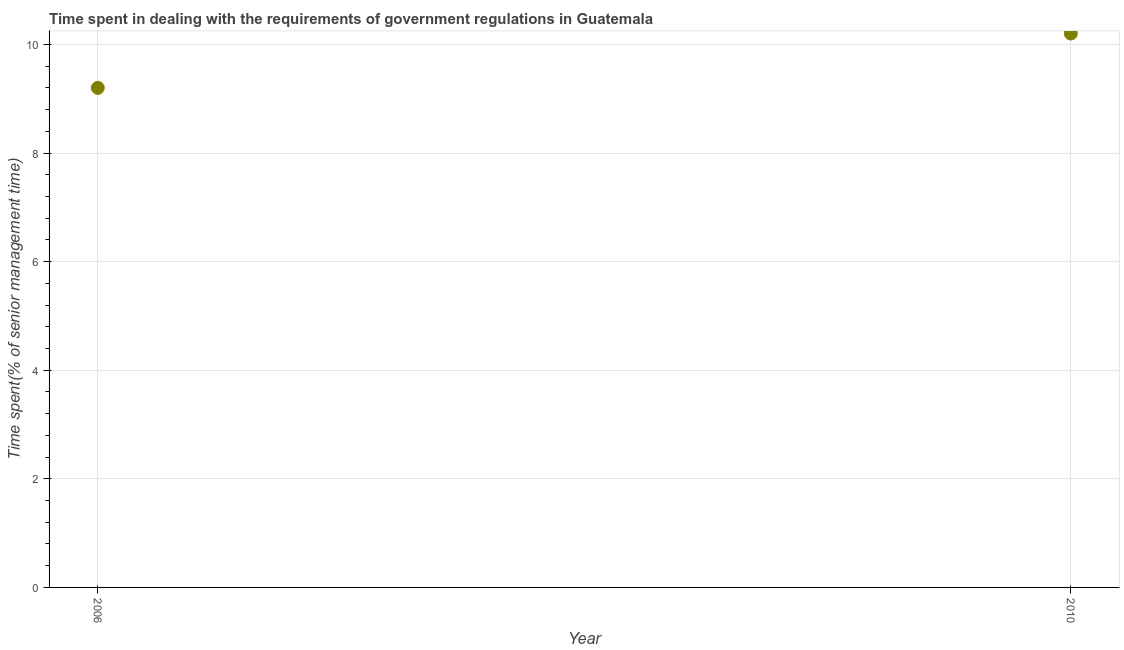Across all years, what is the minimum time spent in dealing with government regulations?
Offer a very short reply. 9.2. What is the difference between the time spent in dealing with government regulations in 2006 and 2010?
Your response must be concise. -1. What is the average time spent in dealing with government regulations per year?
Your answer should be very brief. 9.7. In how many years, is the time spent in dealing with government regulations greater than 8.4 %?
Provide a succinct answer. 2. Do a majority of the years between 2006 and 2010 (inclusive) have time spent in dealing with government regulations greater than 6.8 %?
Provide a short and direct response. Yes. What is the ratio of the time spent in dealing with government regulations in 2006 to that in 2010?
Keep it short and to the point. 0.9. In how many years, is the time spent in dealing with government regulations greater than the average time spent in dealing with government regulations taken over all years?
Your answer should be very brief. 1. How many dotlines are there?
Your answer should be compact. 1. How many years are there in the graph?
Provide a short and direct response. 2. What is the difference between two consecutive major ticks on the Y-axis?
Offer a very short reply. 2. Are the values on the major ticks of Y-axis written in scientific E-notation?
Ensure brevity in your answer.  No. Does the graph contain grids?
Provide a short and direct response. Yes. What is the title of the graph?
Ensure brevity in your answer.  Time spent in dealing with the requirements of government regulations in Guatemala. What is the label or title of the X-axis?
Offer a very short reply. Year. What is the label or title of the Y-axis?
Offer a very short reply. Time spent(% of senior management time). What is the Time spent(% of senior management time) in 2006?
Your answer should be compact. 9.2. What is the Time spent(% of senior management time) in 2010?
Your response must be concise. 10.2. What is the difference between the Time spent(% of senior management time) in 2006 and 2010?
Ensure brevity in your answer.  -1. What is the ratio of the Time spent(% of senior management time) in 2006 to that in 2010?
Ensure brevity in your answer.  0.9. 